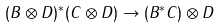Convert formula to latex. <formula><loc_0><loc_0><loc_500><loc_500>( B \otimes D ) ^ { * } ( C \otimes D ) \to ( B ^ { * } C ) \otimes D</formula> 